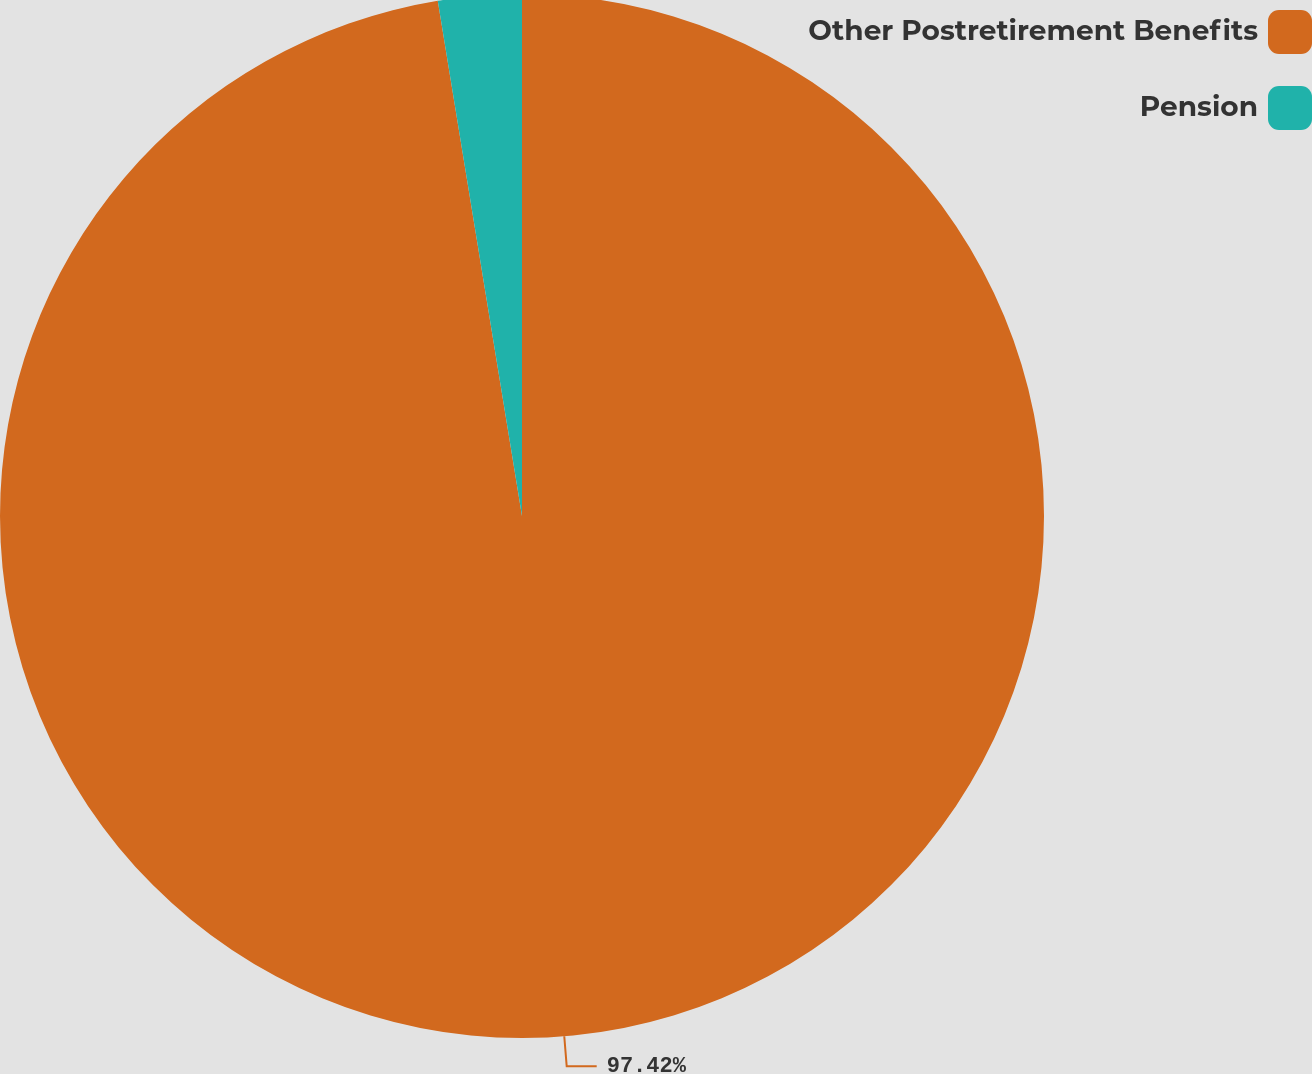Convert chart to OTSL. <chart><loc_0><loc_0><loc_500><loc_500><pie_chart><fcel>Other Postretirement Benefits<fcel>Pension<nl><fcel>97.42%<fcel>2.58%<nl></chart> 